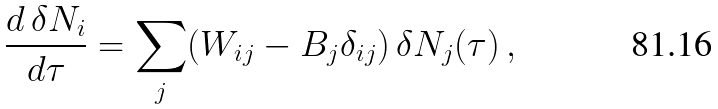<formula> <loc_0><loc_0><loc_500><loc_500>\frac { d \, \delta N _ { i } } { d \tau } = \sum _ { j } ( W _ { i j } - B _ { j } \delta _ { i j } ) \, \delta N _ { j } ( \tau ) \, ,</formula> 